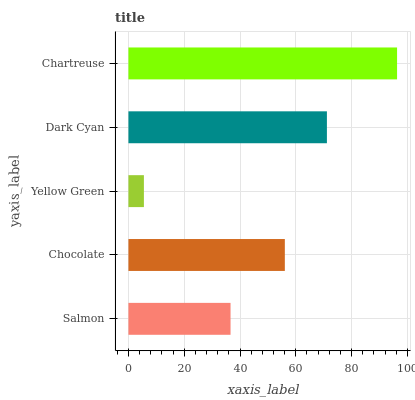Is Yellow Green the minimum?
Answer yes or no. Yes. Is Chartreuse the maximum?
Answer yes or no. Yes. Is Chocolate the minimum?
Answer yes or no. No. Is Chocolate the maximum?
Answer yes or no. No. Is Chocolate greater than Salmon?
Answer yes or no. Yes. Is Salmon less than Chocolate?
Answer yes or no. Yes. Is Salmon greater than Chocolate?
Answer yes or no. No. Is Chocolate less than Salmon?
Answer yes or no. No. Is Chocolate the high median?
Answer yes or no. Yes. Is Chocolate the low median?
Answer yes or no. Yes. Is Yellow Green the high median?
Answer yes or no. No. Is Dark Cyan the low median?
Answer yes or no. No. 